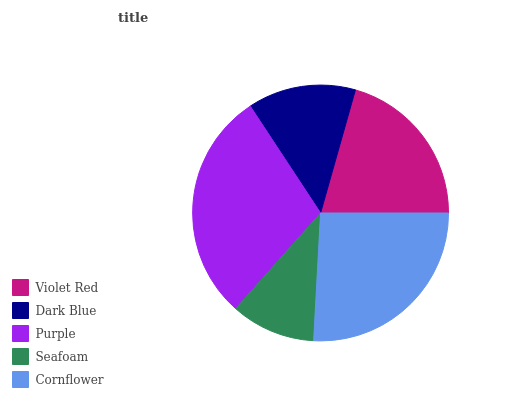Is Seafoam the minimum?
Answer yes or no. Yes. Is Purple the maximum?
Answer yes or no. Yes. Is Dark Blue the minimum?
Answer yes or no. No. Is Dark Blue the maximum?
Answer yes or no. No. Is Violet Red greater than Dark Blue?
Answer yes or no. Yes. Is Dark Blue less than Violet Red?
Answer yes or no. Yes. Is Dark Blue greater than Violet Red?
Answer yes or no. No. Is Violet Red less than Dark Blue?
Answer yes or no. No. Is Violet Red the high median?
Answer yes or no. Yes. Is Violet Red the low median?
Answer yes or no. Yes. Is Purple the high median?
Answer yes or no. No. Is Purple the low median?
Answer yes or no. No. 